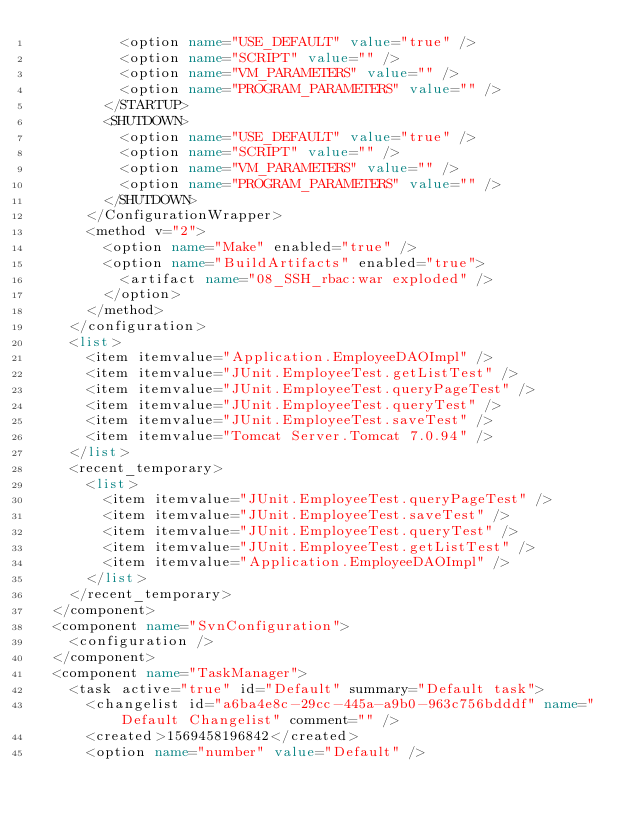Convert code to text. <code><loc_0><loc_0><loc_500><loc_500><_XML_>          <option name="USE_DEFAULT" value="true" />
          <option name="SCRIPT" value="" />
          <option name="VM_PARAMETERS" value="" />
          <option name="PROGRAM_PARAMETERS" value="" />
        </STARTUP>
        <SHUTDOWN>
          <option name="USE_DEFAULT" value="true" />
          <option name="SCRIPT" value="" />
          <option name="VM_PARAMETERS" value="" />
          <option name="PROGRAM_PARAMETERS" value="" />
        </SHUTDOWN>
      </ConfigurationWrapper>
      <method v="2">
        <option name="Make" enabled="true" />
        <option name="BuildArtifacts" enabled="true">
          <artifact name="08_SSH_rbac:war exploded" />
        </option>
      </method>
    </configuration>
    <list>
      <item itemvalue="Application.EmployeeDAOImpl" />
      <item itemvalue="JUnit.EmployeeTest.getListTest" />
      <item itemvalue="JUnit.EmployeeTest.queryPageTest" />
      <item itemvalue="JUnit.EmployeeTest.queryTest" />
      <item itemvalue="JUnit.EmployeeTest.saveTest" />
      <item itemvalue="Tomcat Server.Tomcat 7.0.94" />
    </list>
    <recent_temporary>
      <list>
        <item itemvalue="JUnit.EmployeeTest.queryPageTest" />
        <item itemvalue="JUnit.EmployeeTest.saveTest" />
        <item itemvalue="JUnit.EmployeeTest.queryTest" />
        <item itemvalue="JUnit.EmployeeTest.getListTest" />
        <item itemvalue="Application.EmployeeDAOImpl" />
      </list>
    </recent_temporary>
  </component>
  <component name="SvnConfiguration">
    <configuration />
  </component>
  <component name="TaskManager">
    <task active="true" id="Default" summary="Default task">
      <changelist id="a6ba4e8c-29cc-445a-a9b0-963c756bdddf" name="Default Changelist" comment="" />
      <created>1569458196842</created>
      <option name="number" value="Default" /></code> 